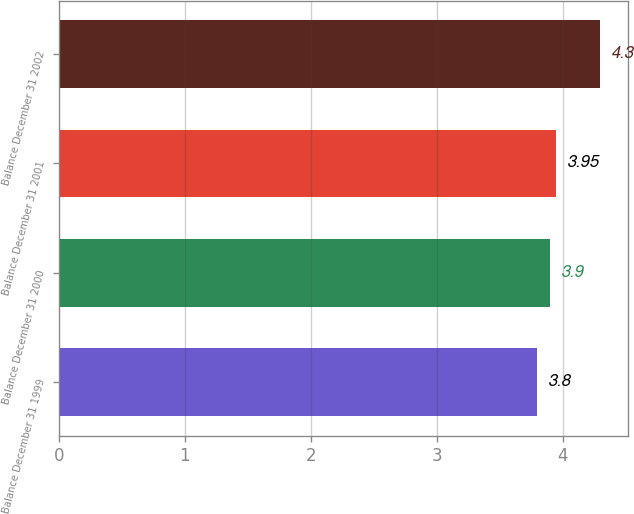<chart> <loc_0><loc_0><loc_500><loc_500><bar_chart><fcel>Balance December 31 1999<fcel>Balance December 31 2000<fcel>Balance December 31 2001<fcel>Balance December 31 2002<nl><fcel>3.8<fcel>3.9<fcel>3.95<fcel>4.3<nl></chart> 